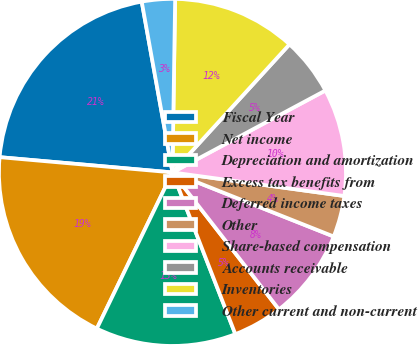Convert chart. <chart><loc_0><loc_0><loc_500><loc_500><pie_chart><fcel>Fiscal Year<fcel>Net income<fcel>Depreciation and amortization<fcel>Excess tax benefits from<fcel>Deferred income taxes<fcel>Other<fcel>Share-based compensation<fcel>Accounts receivable<fcel>Inventories<fcel>Other current and non-current<nl><fcel>20.77%<fcel>19.23%<fcel>13.08%<fcel>4.62%<fcel>8.46%<fcel>3.85%<fcel>10.0%<fcel>5.39%<fcel>11.54%<fcel>3.08%<nl></chart> 